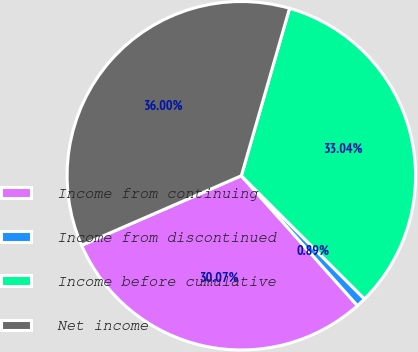Convert chart. <chart><loc_0><loc_0><loc_500><loc_500><pie_chart><fcel>Income from continuing<fcel>Income from discontinued<fcel>Income before cumulative<fcel>Net income<nl><fcel>30.07%<fcel>0.89%<fcel>33.04%<fcel>36.0%<nl></chart> 